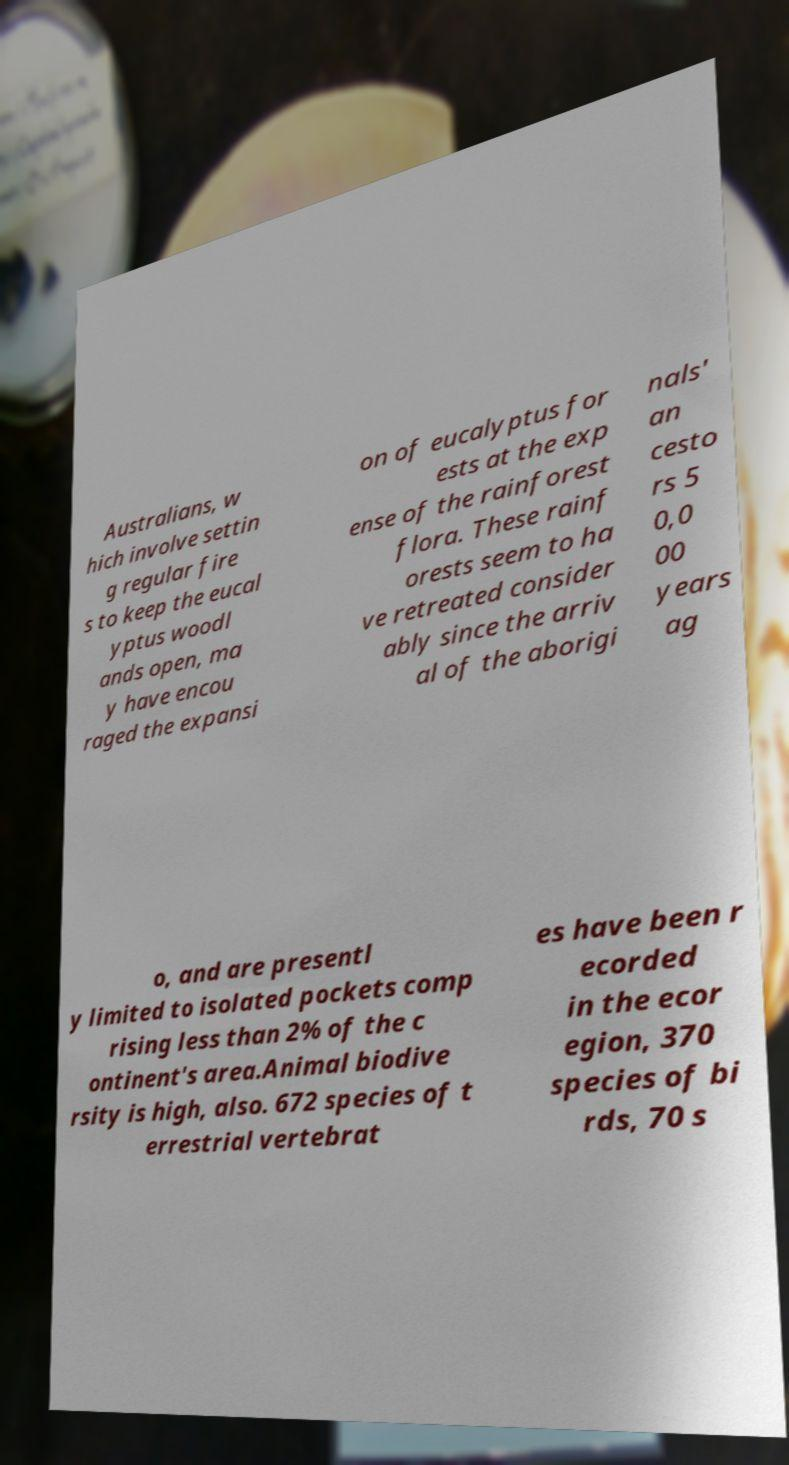Please read and relay the text visible in this image. What does it say? Australians, w hich involve settin g regular fire s to keep the eucal yptus woodl ands open, ma y have encou raged the expansi on of eucalyptus for ests at the exp ense of the rainforest flora. These rainf orests seem to ha ve retreated consider ably since the arriv al of the aborigi nals' an cesto rs 5 0,0 00 years ag o, and are presentl y limited to isolated pockets comp rising less than 2% of the c ontinent's area.Animal biodive rsity is high, also. 672 species of t errestrial vertebrat es have been r ecorded in the ecor egion, 370 species of bi rds, 70 s 